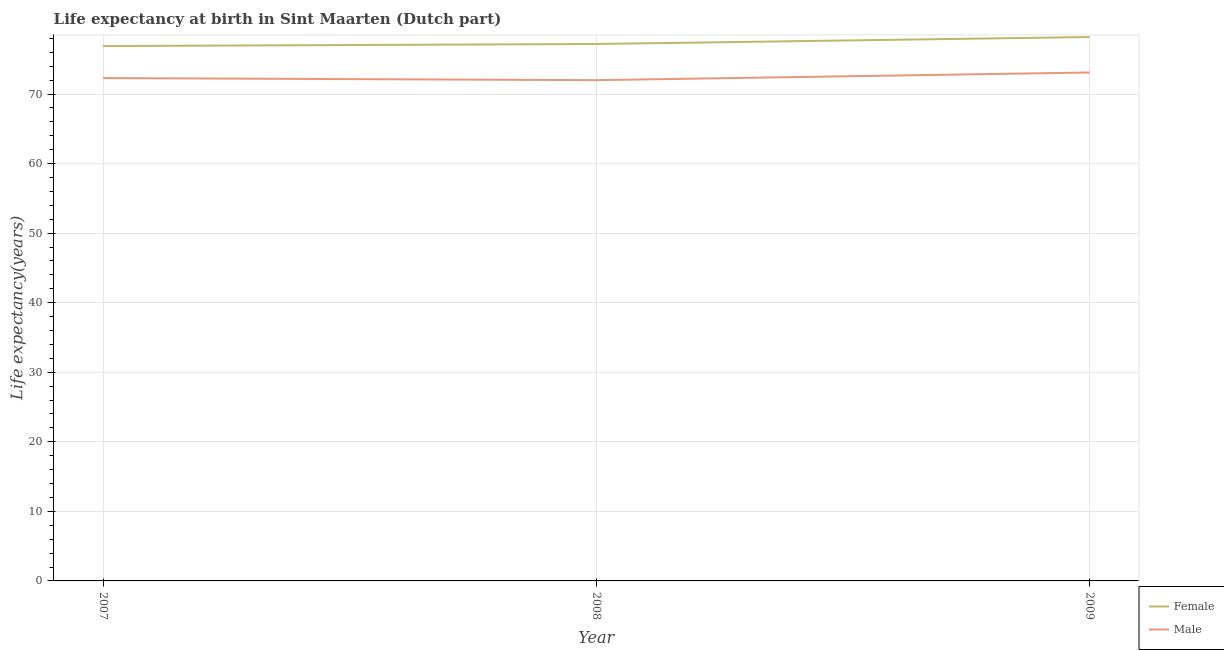Does the line corresponding to life expectancy(male) intersect with the line corresponding to life expectancy(female)?
Ensure brevity in your answer.  No. What is the life expectancy(male) in 2007?
Give a very brief answer. 72.3. Across all years, what is the maximum life expectancy(female)?
Your answer should be compact. 78.2. In which year was the life expectancy(female) maximum?
Provide a short and direct response. 2009. In which year was the life expectancy(male) minimum?
Offer a terse response. 2008. What is the total life expectancy(female) in the graph?
Offer a very short reply. 232.3. What is the difference between the life expectancy(female) in 2007 and that in 2009?
Your answer should be very brief. -1.3. What is the difference between the life expectancy(female) in 2008 and the life expectancy(male) in 2009?
Give a very brief answer. 4.1. What is the average life expectancy(male) per year?
Your response must be concise. 72.47. In the year 2008, what is the difference between the life expectancy(female) and life expectancy(male)?
Your answer should be compact. 5.2. In how many years, is the life expectancy(male) greater than 28 years?
Offer a terse response. 3. What is the ratio of the life expectancy(female) in 2007 to that in 2008?
Your answer should be compact. 1. Is the life expectancy(male) in 2007 less than that in 2009?
Your answer should be very brief. Yes. What is the difference between the highest and the second highest life expectancy(female)?
Offer a very short reply. 1. What is the difference between the highest and the lowest life expectancy(male)?
Ensure brevity in your answer.  1.1. In how many years, is the life expectancy(female) greater than the average life expectancy(female) taken over all years?
Your answer should be compact. 1. Is the sum of the life expectancy(male) in 2007 and 2009 greater than the maximum life expectancy(female) across all years?
Keep it short and to the point. Yes. Does the life expectancy(male) monotonically increase over the years?
Give a very brief answer. No. How many years are there in the graph?
Give a very brief answer. 3. What is the difference between two consecutive major ticks on the Y-axis?
Ensure brevity in your answer.  10. Are the values on the major ticks of Y-axis written in scientific E-notation?
Offer a very short reply. No. How many legend labels are there?
Your response must be concise. 2. How are the legend labels stacked?
Offer a very short reply. Vertical. What is the title of the graph?
Keep it short and to the point. Life expectancy at birth in Sint Maarten (Dutch part). What is the label or title of the X-axis?
Provide a short and direct response. Year. What is the label or title of the Y-axis?
Ensure brevity in your answer.  Life expectancy(years). What is the Life expectancy(years) of Female in 2007?
Provide a succinct answer. 76.9. What is the Life expectancy(years) in Male in 2007?
Your answer should be compact. 72.3. What is the Life expectancy(years) in Female in 2008?
Ensure brevity in your answer.  77.2. What is the Life expectancy(years) in Male in 2008?
Ensure brevity in your answer.  72. What is the Life expectancy(years) in Female in 2009?
Your response must be concise. 78.2. What is the Life expectancy(years) in Male in 2009?
Your response must be concise. 73.1. Across all years, what is the maximum Life expectancy(years) in Female?
Offer a terse response. 78.2. Across all years, what is the maximum Life expectancy(years) of Male?
Offer a terse response. 73.1. Across all years, what is the minimum Life expectancy(years) of Female?
Ensure brevity in your answer.  76.9. What is the total Life expectancy(years) of Female in the graph?
Provide a short and direct response. 232.3. What is the total Life expectancy(years) in Male in the graph?
Offer a terse response. 217.4. What is the difference between the Life expectancy(years) in Male in 2007 and that in 2008?
Your answer should be very brief. 0.3. What is the difference between the Life expectancy(years) in Male in 2008 and that in 2009?
Ensure brevity in your answer.  -1.1. What is the difference between the Life expectancy(years) in Female in 2007 and the Life expectancy(years) in Male in 2008?
Your response must be concise. 4.9. What is the difference between the Life expectancy(years) of Female in 2007 and the Life expectancy(years) of Male in 2009?
Provide a succinct answer. 3.8. What is the difference between the Life expectancy(years) of Female in 2008 and the Life expectancy(years) of Male in 2009?
Offer a very short reply. 4.1. What is the average Life expectancy(years) in Female per year?
Your answer should be very brief. 77.43. What is the average Life expectancy(years) in Male per year?
Keep it short and to the point. 72.47. In the year 2007, what is the difference between the Life expectancy(years) of Female and Life expectancy(years) of Male?
Give a very brief answer. 4.6. In the year 2008, what is the difference between the Life expectancy(years) of Female and Life expectancy(years) of Male?
Provide a short and direct response. 5.2. In the year 2009, what is the difference between the Life expectancy(years) in Female and Life expectancy(years) in Male?
Your answer should be very brief. 5.1. What is the ratio of the Life expectancy(years) of Female in 2007 to that in 2008?
Provide a short and direct response. 1. What is the ratio of the Life expectancy(years) in Male in 2007 to that in 2008?
Offer a terse response. 1. What is the ratio of the Life expectancy(years) of Female in 2007 to that in 2009?
Your answer should be very brief. 0.98. What is the ratio of the Life expectancy(years) of Male in 2007 to that in 2009?
Keep it short and to the point. 0.99. What is the ratio of the Life expectancy(years) in Female in 2008 to that in 2009?
Give a very brief answer. 0.99. What is the difference between the highest and the lowest Life expectancy(years) of Female?
Your response must be concise. 1.3. 